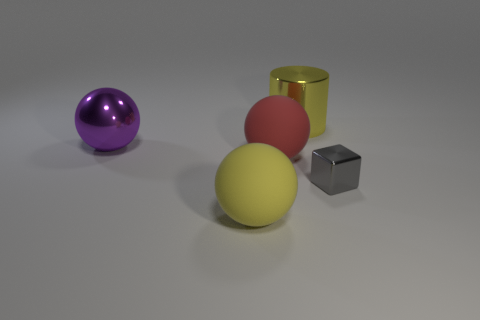Can you tell me the approximate size of the red sphere compared to the yellow one? The red sphere seems to be slightly smaller than the yellow one, suggesting it might be around three-quarters the size of the yellow sphere. 